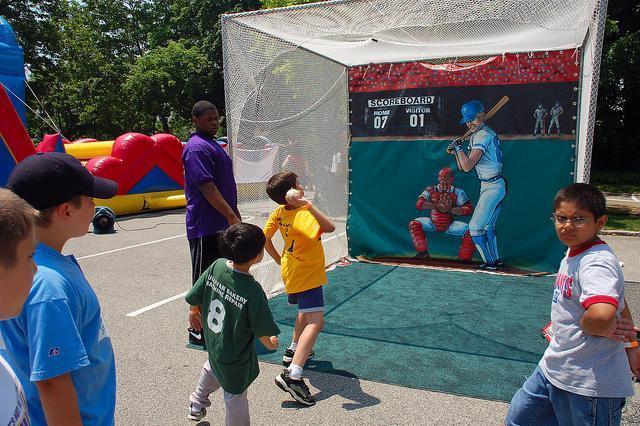How many people can be seen?
Give a very brief answer. 8. How many toilet covers are there?
Give a very brief answer. 0. 